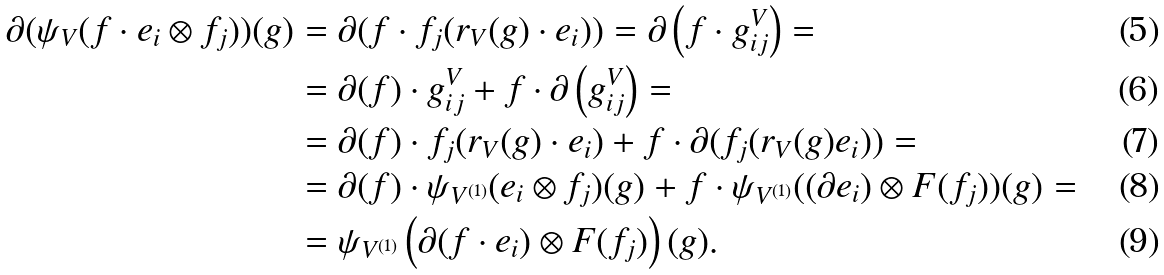<formula> <loc_0><loc_0><loc_500><loc_500>\partial ( \psi _ { V } ( f \cdot e _ { i } \otimes f _ { j } ) ) ( g ) & = \partial ( f \cdot f _ { j } ( r _ { V } ( g ) \cdot e _ { i } ) ) = \partial \left ( f \cdot g _ { i j } ^ { V } \right ) = \\ & = \partial ( f ) \cdot g _ { i j } ^ { V } + f \cdot \partial \left ( g _ { i j } ^ { V } \right ) = \\ & = \partial ( f ) \cdot f _ { j } ( r _ { V } ( g ) \cdot e _ { i } ) + f \cdot \partial ( f _ { j } ( r _ { V } ( g ) e _ { i } ) ) = \\ & = \partial ( f ) \cdot \psi _ { V ^ { ( 1 ) } } ( e _ { i } \otimes f _ { j } ) ( g ) + f \cdot \psi _ { V ^ { ( 1 ) } } ( ( \partial e _ { i } ) \otimes F ( f _ { j } ) ) ( g ) = \\ & = \psi _ { V ^ { ( 1 ) } } \left ( \partial ( f \cdot e _ { i } ) \otimes F ( f _ { j } ) \right ) ( g ) .</formula> 